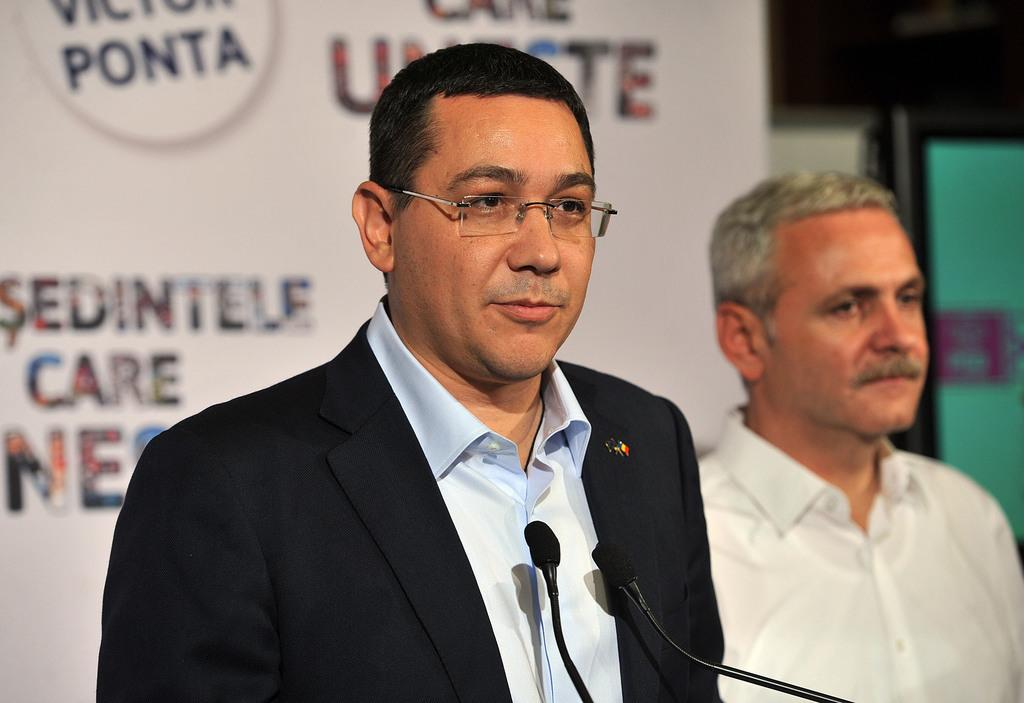What is the man in the foreground of the image wearing? The man in the foreground of the image is wearing a suit. What is in front of the man in the foreground? There are microphones in front of the man in the foreground. Can you describe the person on the right side of the image? There is another man on the right side of the image. What can be seen in the background of the image? There is a banner in the background of the image. What book is the man reading in the image? There is no book present in the image, and the man is not reading. 